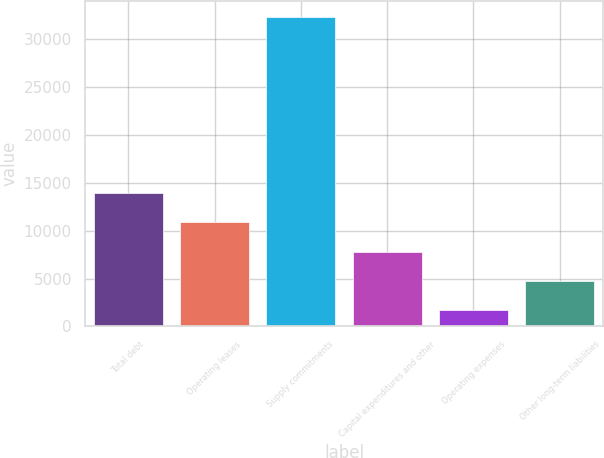Convert chart to OTSL. <chart><loc_0><loc_0><loc_500><loc_500><bar_chart><fcel>Total debt<fcel>Operating leases<fcel>Supply commitments<fcel>Capital expenditures and other<fcel>Operating expenses<fcel>Other long-term liabilities<nl><fcel>13956.6<fcel>10886.7<fcel>32376<fcel>7816.8<fcel>1677<fcel>4746.9<nl></chart> 